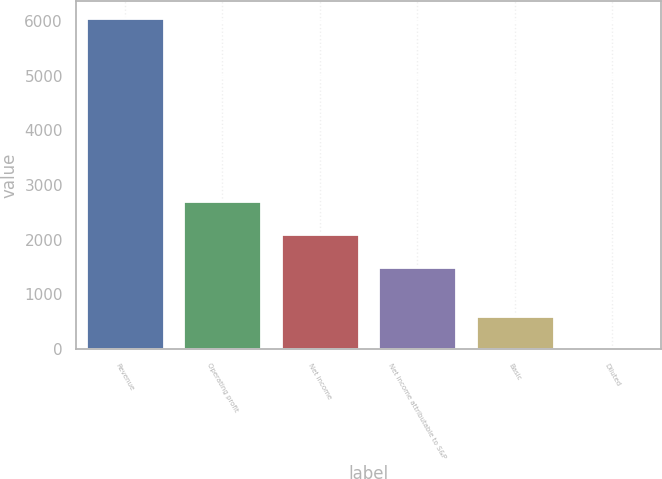Convert chart to OTSL. <chart><loc_0><loc_0><loc_500><loc_500><bar_chart><fcel>Revenue<fcel>Operating profit<fcel>Net income<fcel>Net income attributable to S&P<fcel>Basic<fcel>Diluted<nl><fcel>6063<fcel>2707.44<fcel>2101.72<fcel>1496<fcel>611.5<fcel>5.78<nl></chart> 